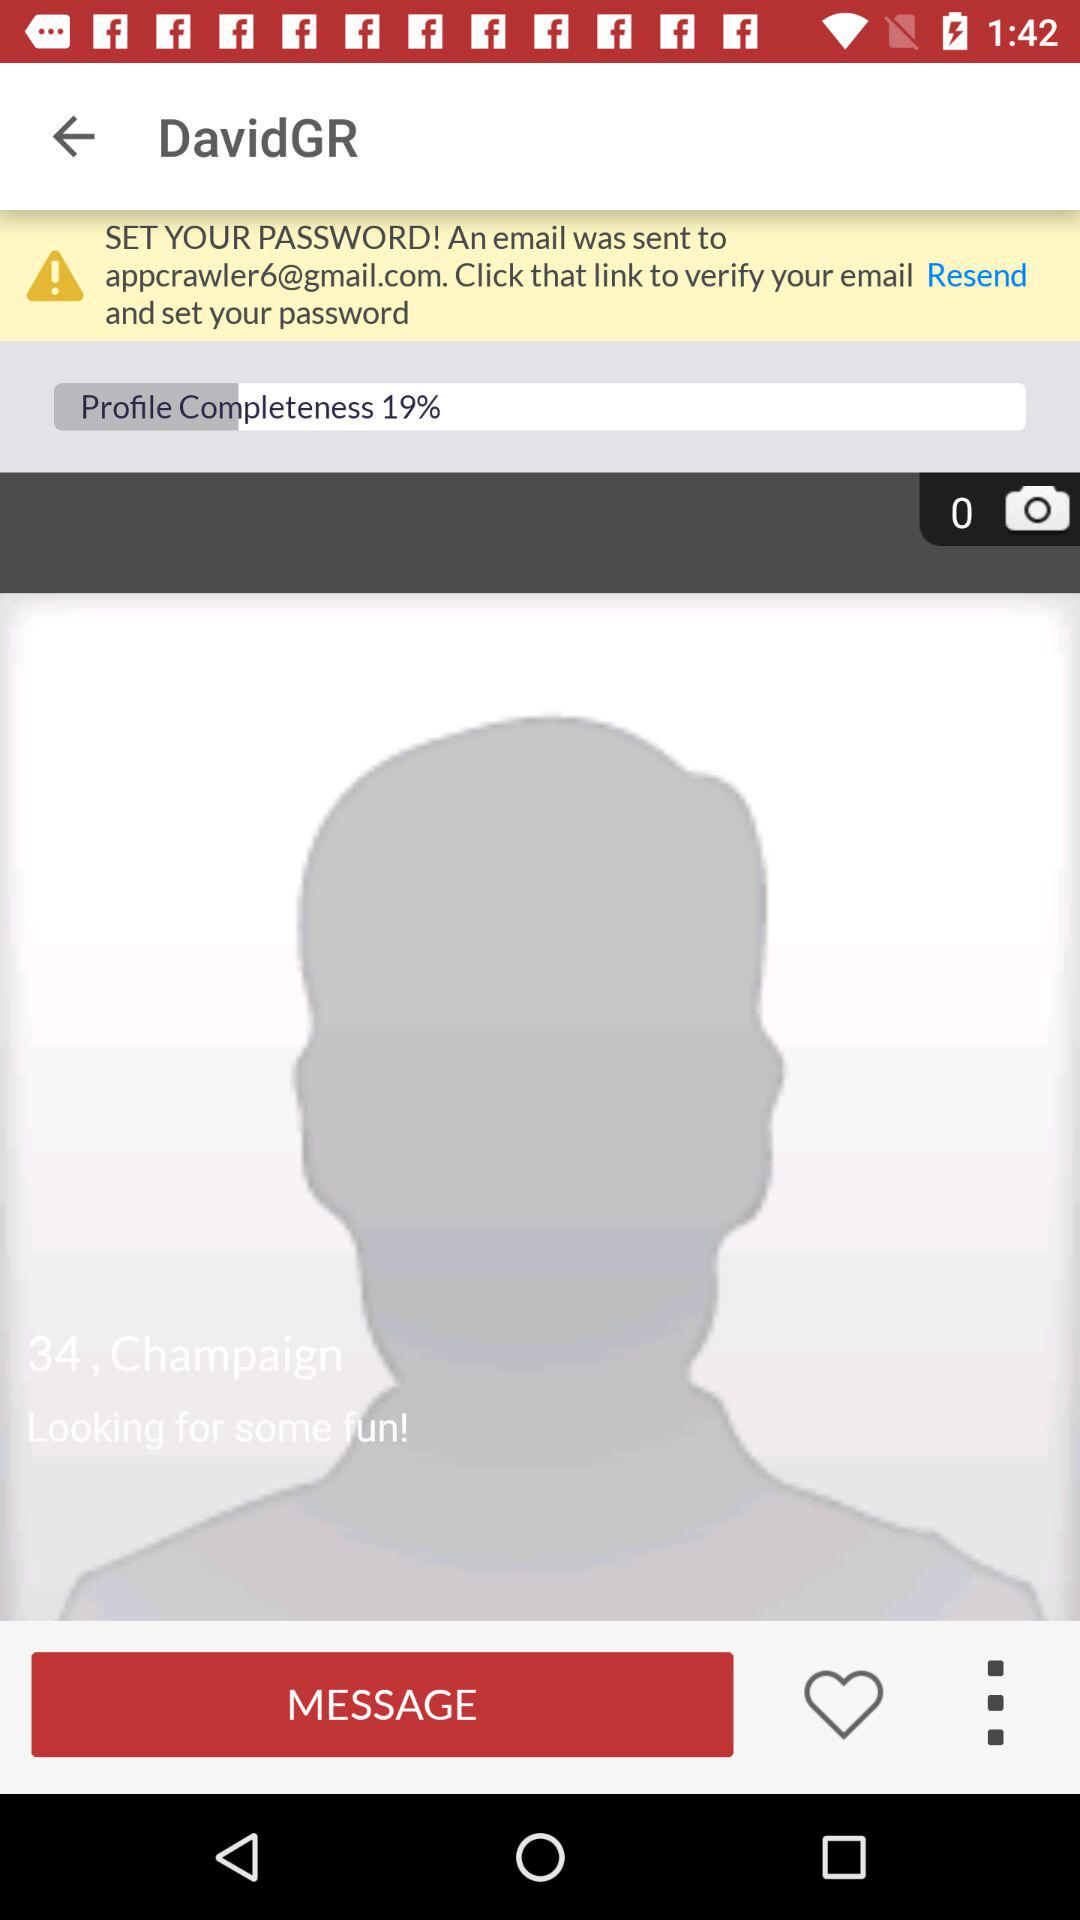What percentage is the profile completeness?
Answer the question using a single word or phrase. 19% 